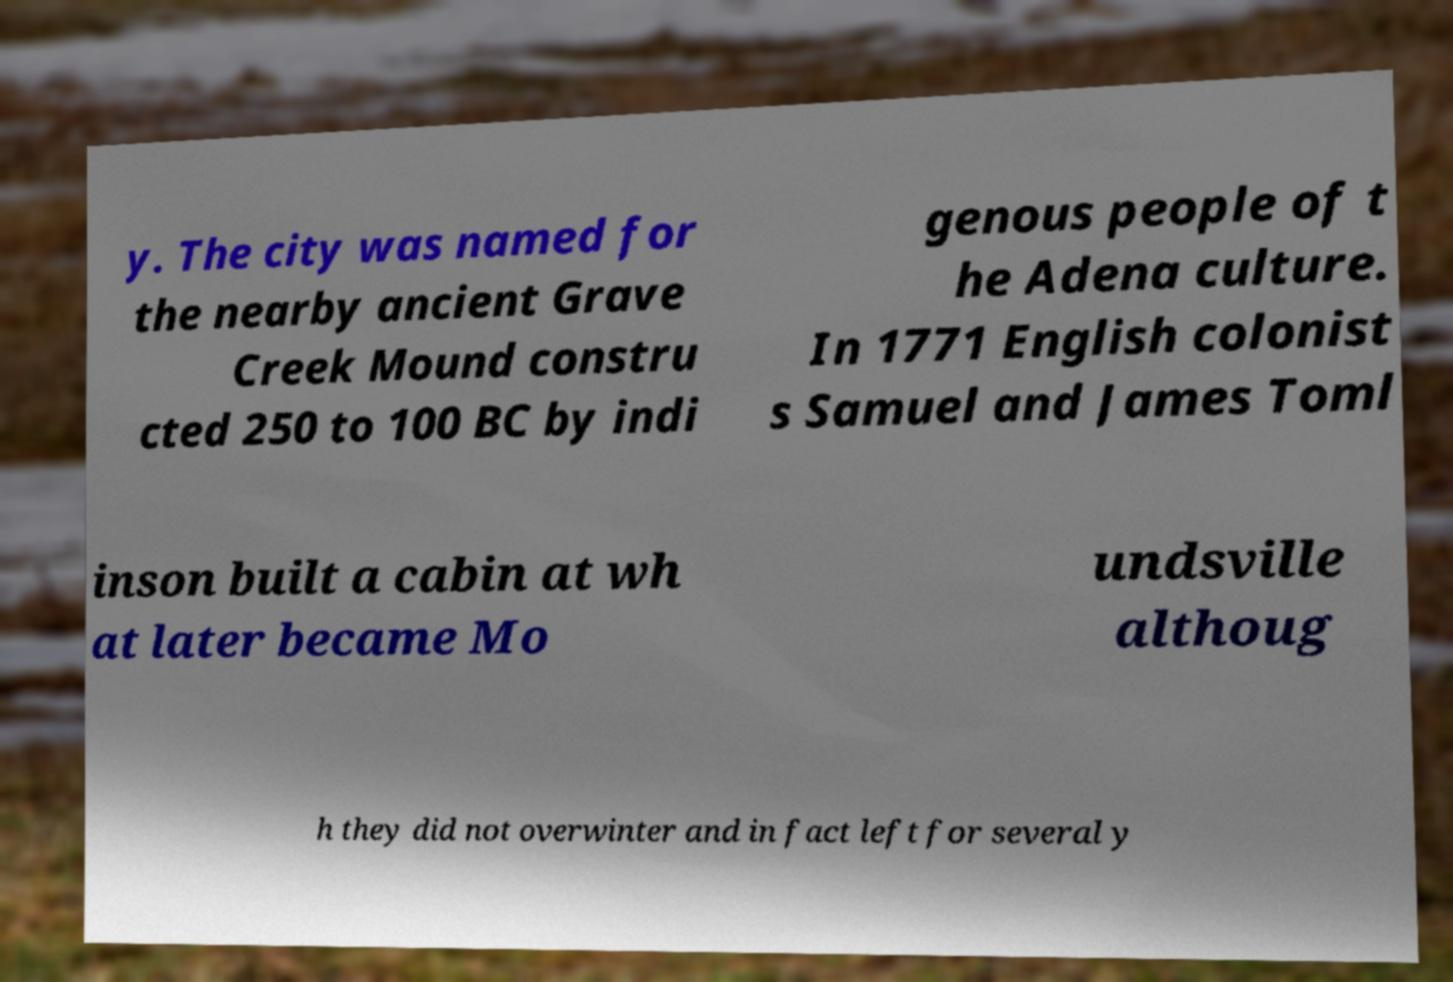Could you extract and type out the text from this image? y. The city was named for the nearby ancient Grave Creek Mound constru cted 250 to 100 BC by indi genous people of t he Adena culture. In 1771 English colonist s Samuel and James Toml inson built a cabin at wh at later became Mo undsville althoug h they did not overwinter and in fact left for several y 